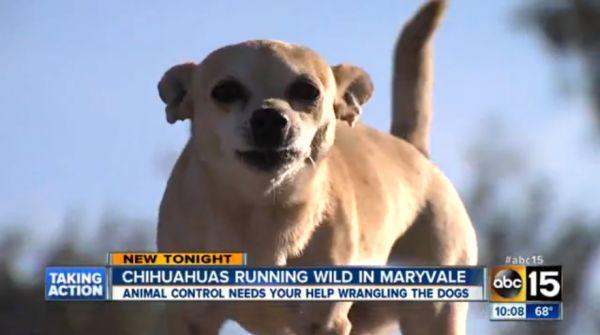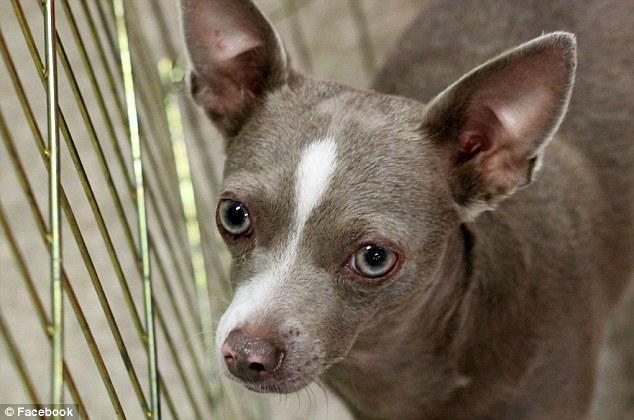The first image is the image on the left, the second image is the image on the right. Examine the images to the left and right. Is the description "An image contains a chihuahua snarling and showing its teeth." accurate? Answer yes or no. No. 